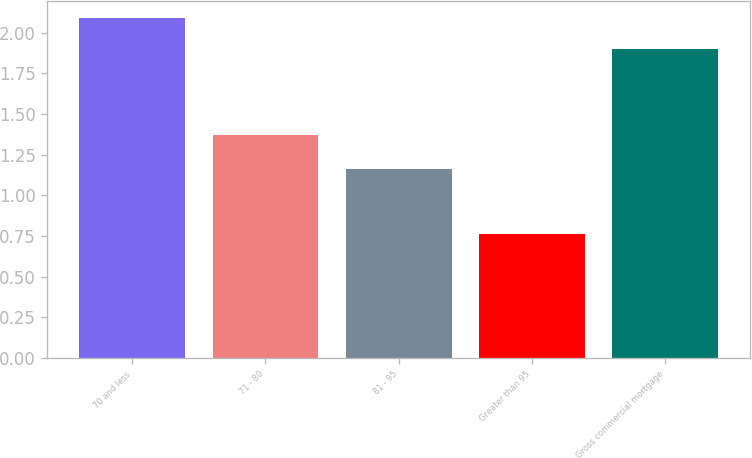Convert chart to OTSL. <chart><loc_0><loc_0><loc_500><loc_500><bar_chart><fcel>70 and less<fcel>71 - 80<fcel>81 - 95<fcel>Greater than 95<fcel>Gross commercial mortgage<nl><fcel>2.09<fcel>1.37<fcel>1.16<fcel>0.76<fcel>1.9<nl></chart> 